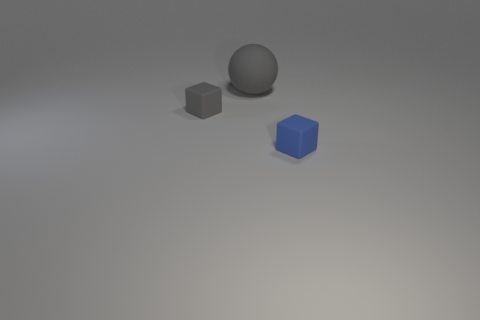Are there any other things that have the same shape as the large gray matte object?
Make the answer very short. No. Is the big gray sphere behind the tiny blue rubber thing made of the same material as the blue thing?
Keep it short and to the point. Yes. There is a rubber cube that is behind the small matte object to the right of the large rubber thing; how big is it?
Give a very brief answer. Small. How many gray matte blocks have the same size as the gray matte ball?
Ensure brevity in your answer.  0. There is a object behind the small gray thing; is it the same color as the rubber cube that is to the left of the big rubber object?
Your response must be concise. Yes. Are there any small rubber blocks on the right side of the blue matte object?
Make the answer very short. No. The object that is both behind the tiny blue matte thing and on the right side of the tiny gray rubber thing is what color?
Offer a very short reply. Gray. Are there any rubber blocks of the same color as the large matte ball?
Ensure brevity in your answer.  Yes. There is a object behind the small gray rubber thing; how big is it?
Offer a terse response. Large. The blue object is what size?
Your answer should be compact. Small. 